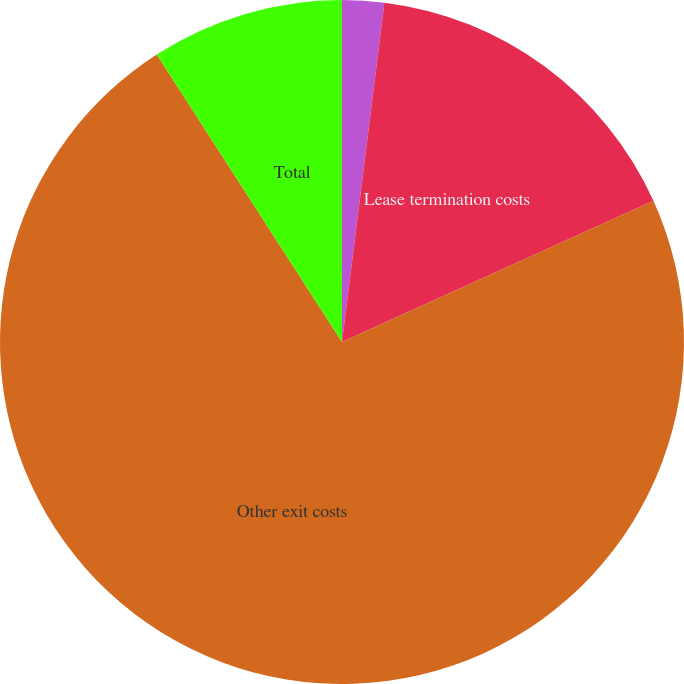Convert chart. <chart><loc_0><loc_0><loc_500><loc_500><pie_chart><fcel>Severance and termination<fcel>Lease termination costs<fcel>Other exit costs<fcel>Total<nl><fcel>1.98%<fcel>16.24%<fcel>72.67%<fcel>9.11%<nl></chart> 